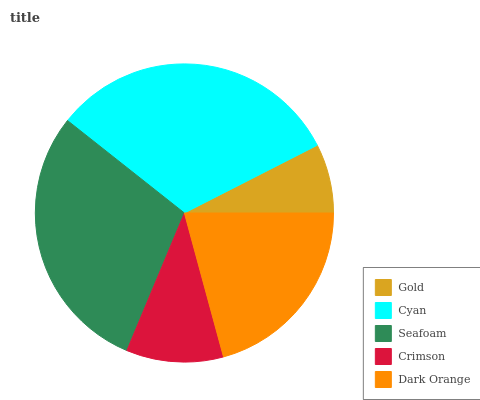Is Gold the minimum?
Answer yes or no. Yes. Is Cyan the maximum?
Answer yes or no. Yes. Is Seafoam the minimum?
Answer yes or no. No. Is Seafoam the maximum?
Answer yes or no. No. Is Cyan greater than Seafoam?
Answer yes or no. Yes. Is Seafoam less than Cyan?
Answer yes or no. Yes. Is Seafoam greater than Cyan?
Answer yes or no. No. Is Cyan less than Seafoam?
Answer yes or no. No. Is Dark Orange the high median?
Answer yes or no. Yes. Is Dark Orange the low median?
Answer yes or no. Yes. Is Cyan the high median?
Answer yes or no. No. Is Seafoam the low median?
Answer yes or no. No. 